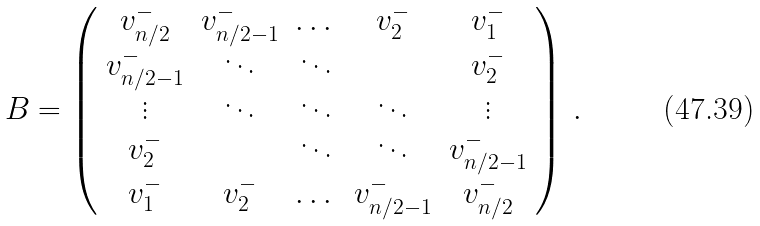<formula> <loc_0><loc_0><loc_500><loc_500>B = \left ( \begin{array} { c c c c c } v _ { n / 2 } ^ { - } & v _ { n / 2 - 1 } ^ { - } & \dots & v _ { 2 } ^ { - } & v _ { 1 } ^ { - } \\ v _ { n / 2 - 1 } ^ { - } & \ddots & \ddots & & v _ { 2 } ^ { - } \\ \vdots & \ddots & \ddots & \ddots & \vdots \\ v _ { 2 } ^ { - } & & \ddots & \ddots & v _ { n / 2 - 1 } ^ { - } \\ v _ { 1 } ^ { - } & v _ { 2 } ^ { - } & \dots & v _ { n / 2 - 1 } ^ { - } & v _ { n / 2 } ^ { - } \\ \end{array} \right ) \, .</formula> 